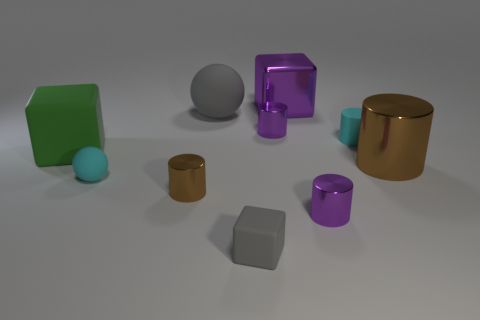Subtract all cyan cylinders. How many cylinders are left? 4 Subtract all tiny rubber cylinders. How many cylinders are left? 4 Subtract all green cylinders. Subtract all purple cubes. How many cylinders are left? 5 Subtract all blocks. How many objects are left? 7 Subtract all large gray spheres. Subtract all large metal things. How many objects are left? 7 Add 3 big cubes. How many big cubes are left? 5 Add 8 small gray rubber cubes. How many small gray rubber cubes exist? 9 Subtract 1 purple blocks. How many objects are left? 9 